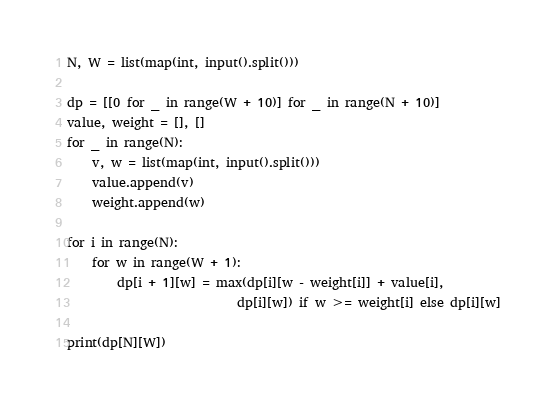Convert code to text. <code><loc_0><loc_0><loc_500><loc_500><_Python_>N, W = list(map(int, input().split()))

dp = [[0 for _ in range(W + 10)] for _ in range(N + 10)]
value, weight = [], []
for _ in range(N):
    v, w = list(map(int, input().split()))
    value.append(v)
    weight.append(w)

for i in range(N):
    for w in range(W + 1):
        dp[i + 1][w] = max(dp[i][w - weight[i]] + value[i],
                           dp[i][w]) if w >= weight[i] else dp[i][w]

print(dp[N][W])

</code> 